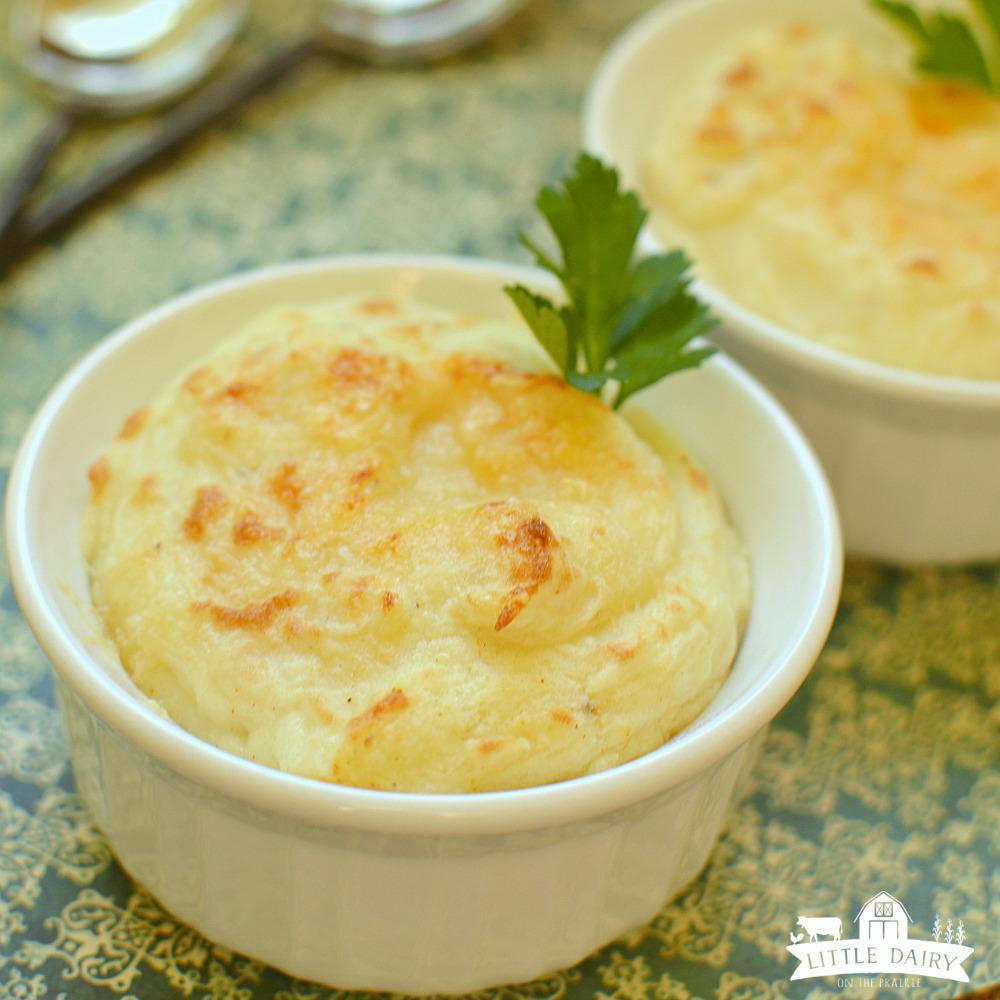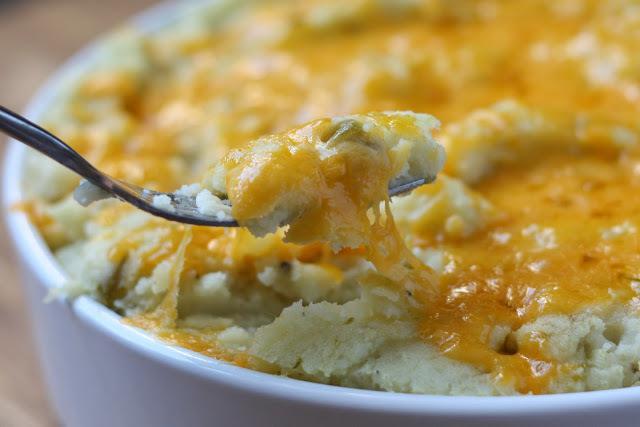The first image is the image on the left, the second image is the image on the right. Assess this claim about the two images: "There is a silvers spoon sitting in a white bowl of food.". Correct or not? Answer yes or no. Yes. The first image is the image on the left, the second image is the image on the right. Assess this claim about the two images: "An eating utensil is lifted above a bowl of food.". Correct or not? Answer yes or no. Yes. 